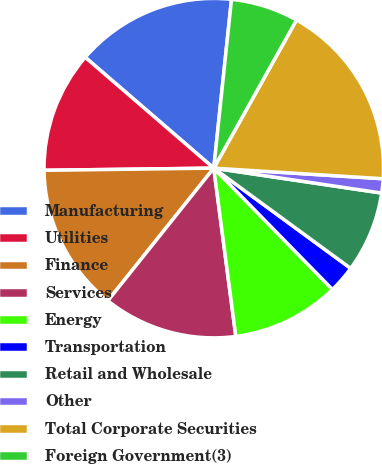Convert chart. <chart><loc_0><loc_0><loc_500><loc_500><pie_chart><fcel>Manufacturing<fcel>Utilities<fcel>Finance<fcel>Services<fcel>Energy<fcel>Transportation<fcel>Retail and Wholesale<fcel>Other<fcel>Total Corporate Securities<fcel>Foreign Government(3)<nl><fcel>15.34%<fcel>11.53%<fcel>14.07%<fcel>12.8%<fcel>10.25%<fcel>2.62%<fcel>7.71%<fcel>1.35%<fcel>17.89%<fcel>6.44%<nl></chart> 